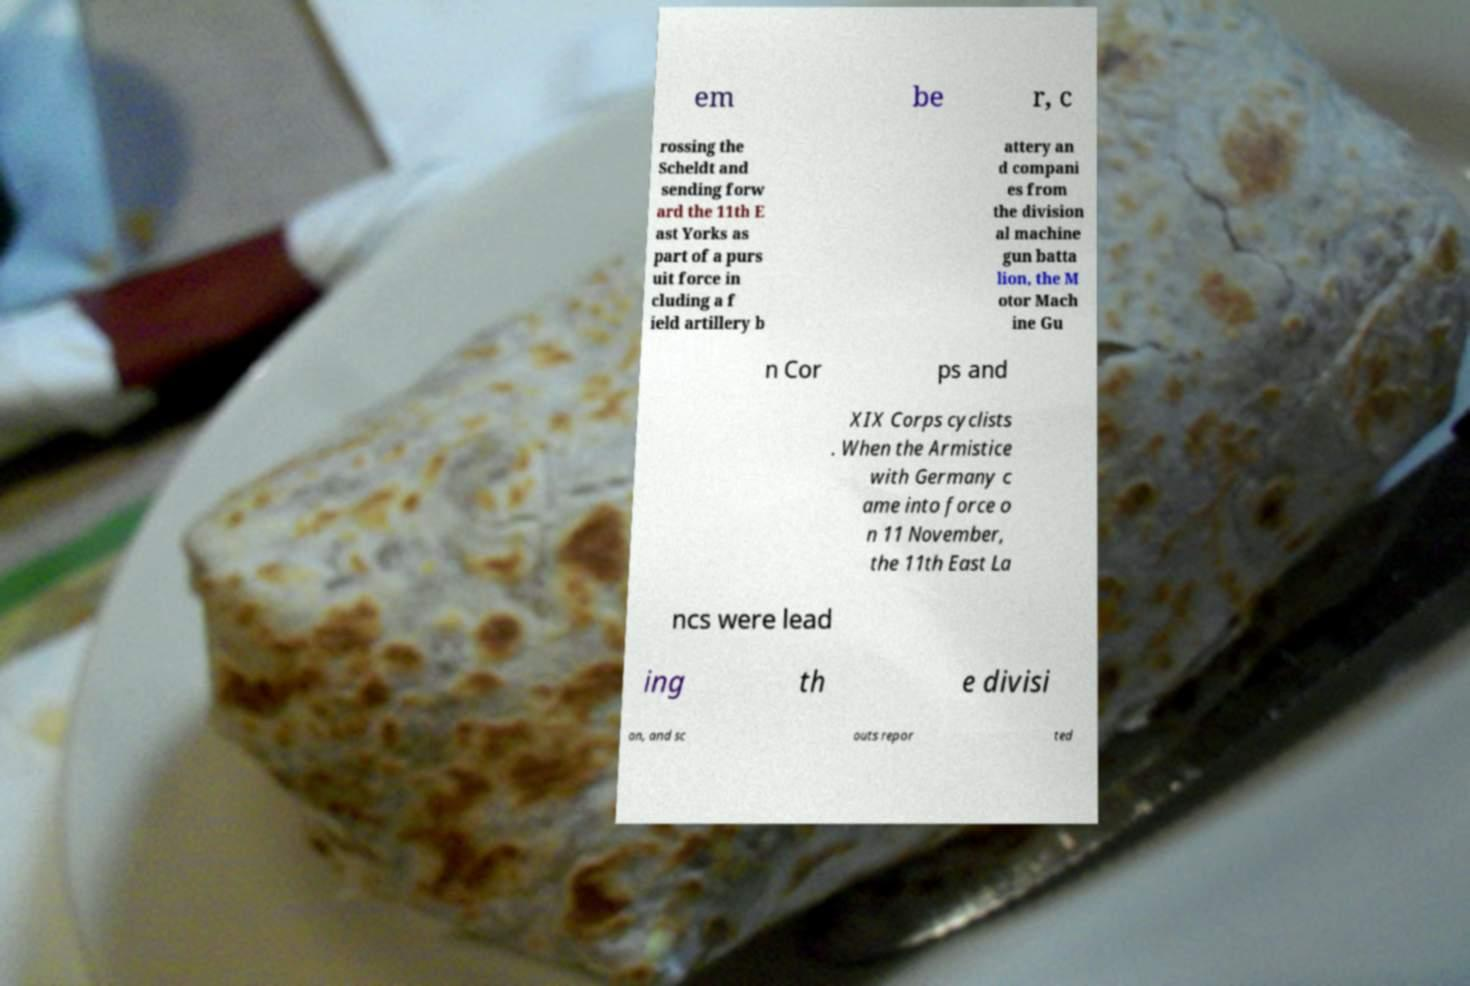For documentation purposes, I need the text within this image transcribed. Could you provide that? em be r, c rossing the Scheldt and sending forw ard the 11th E ast Yorks as part of a purs uit force in cluding a f ield artillery b attery an d compani es from the division al machine gun batta lion, the M otor Mach ine Gu n Cor ps and XIX Corps cyclists . When the Armistice with Germany c ame into force o n 11 November, the 11th East La ncs were lead ing th e divisi on, and sc outs repor ted 